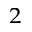Convert formula to latex. <formula><loc_0><loc_0><loc_500><loc_500>^ { 2 }</formula> 